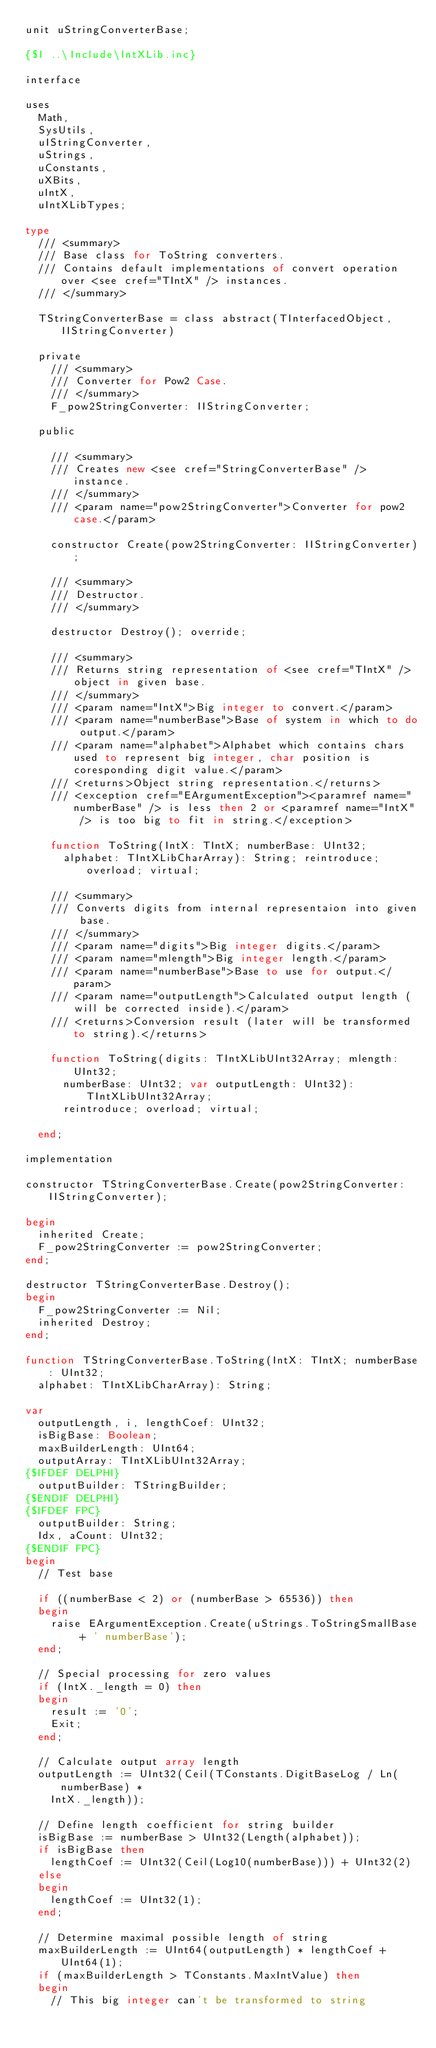Convert code to text. <code><loc_0><loc_0><loc_500><loc_500><_Pascal_>unit uStringConverterBase;

{$I ..\Include\IntXLib.inc}

interface

uses
  Math,
  SysUtils,
  uIStringConverter,
  uStrings,
  uConstants,
  uXBits,
  uIntX,
  uIntXLibTypes;

type
  /// <summary>
  /// Base class for ToString converters.
  /// Contains default implementations of convert operation over <see cref="TIntX" /> instances.
  /// </summary>

  TStringConverterBase = class abstract(TInterfacedObject, IIStringConverter)

  private
    /// <summary>
    /// Converter for Pow2 Case.
    /// </summary>
    F_pow2StringConverter: IIStringConverter;

  public

    /// <summary>
    /// Creates new <see cref="StringConverterBase" /> instance.
    /// </summary>
    /// <param name="pow2StringConverter">Converter for pow2 case.</param>

    constructor Create(pow2StringConverter: IIStringConverter);

    /// <summary>
    /// Destructor.
    /// </summary>

    destructor Destroy(); override;

    /// <summary>
    /// Returns string representation of <see cref="TIntX" /> object in given base.
    /// </summary>
    /// <param name="IntX">Big integer to convert.</param>
    /// <param name="numberBase">Base of system in which to do output.</param>
    /// <param name="alphabet">Alphabet which contains chars used to represent big integer, char position is coresponding digit value.</param>
    /// <returns>Object string representation.</returns>
    /// <exception cref="EArgumentException"><paramref name="numberBase" /> is less then 2 or <paramref name="IntX" /> is too big to fit in string.</exception>

    function ToString(IntX: TIntX; numberBase: UInt32;
      alphabet: TIntXLibCharArray): String; reintroduce; overload; virtual;

    /// <summary>
    /// Converts digits from internal representaion into given base.
    /// </summary>
    /// <param name="digits">Big integer digits.</param>
    /// <param name="mlength">Big integer length.</param>
    /// <param name="numberBase">Base to use for output.</param>
    /// <param name="outputLength">Calculated output length (will be corrected inside).</param>
    /// <returns>Conversion result (later will be transformed to string).</returns>

    function ToString(digits: TIntXLibUInt32Array; mlength: UInt32;
      numberBase: UInt32; var outputLength: UInt32): TIntXLibUInt32Array;
      reintroduce; overload; virtual;

  end;

implementation

constructor TStringConverterBase.Create(pow2StringConverter: IIStringConverter);

begin
  inherited Create;
  F_pow2StringConverter := pow2StringConverter;
end;

destructor TStringConverterBase.Destroy();
begin
  F_pow2StringConverter := Nil;
  inherited Destroy;
end;

function TStringConverterBase.ToString(IntX: TIntX; numberBase: UInt32;
  alphabet: TIntXLibCharArray): String;

var
  outputLength, i, lengthCoef: UInt32;
  isBigBase: Boolean;
  maxBuilderLength: UInt64;
  outputArray: TIntXLibUInt32Array;
{$IFDEF DELPHI}
  outputBuilder: TStringBuilder;
{$ENDIF DELPHI}
{$IFDEF FPC}
  outputBuilder: String;
  Idx, aCount: UInt32;
{$ENDIF FPC}
begin
  // Test base

  if ((numberBase < 2) or (numberBase > 65536)) then
  begin
    raise EArgumentException.Create(uStrings.ToStringSmallBase + ' numberBase');
  end;

  // Special processing for zero values
  if (IntX._length = 0) then
  begin
    result := '0';
    Exit;
  end;

  // Calculate output array length
  outputLength := UInt32(Ceil(TConstants.DigitBaseLog / Ln(numberBase) *
    IntX._length));

  // Define length coefficient for string builder
  isBigBase := numberBase > UInt32(Length(alphabet));
  if isBigBase then
    lengthCoef := UInt32(Ceil(Log10(numberBase))) + UInt32(2)
  else
  begin
    lengthCoef := UInt32(1);
  end;

  // Determine maximal possible length of string
  maxBuilderLength := UInt64(outputLength) * lengthCoef + UInt64(1);
  if (maxBuilderLength > TConstants.MaxIntValue) then
  begin
    // This big integer can't be transformed to string</code> 